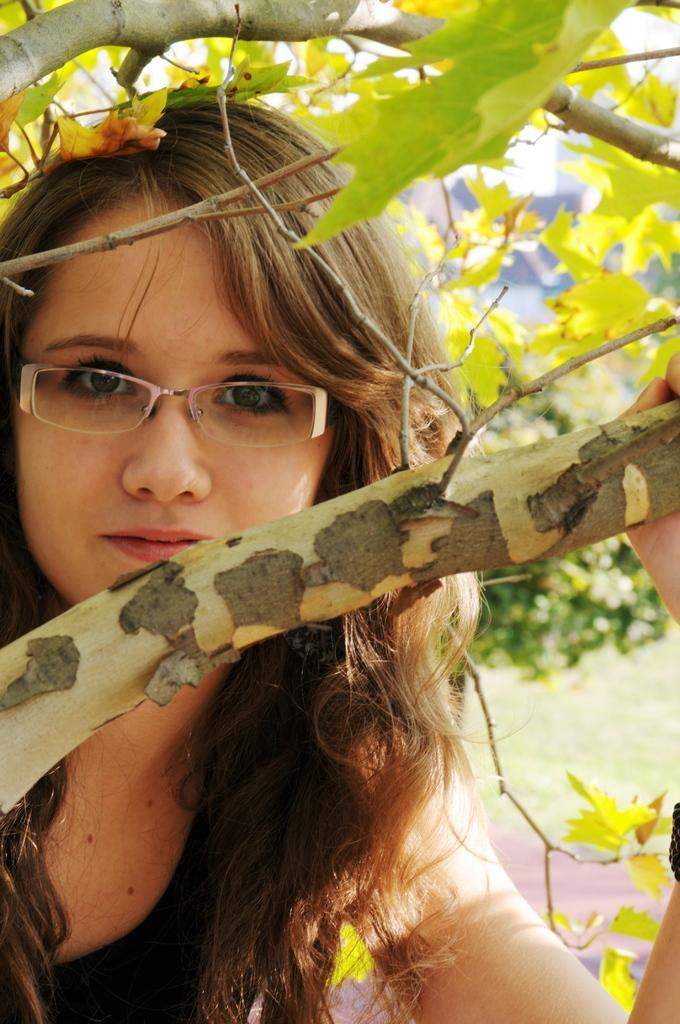What is the main subject of the image? There is a person standing in the image. What is the person wearing? The person is wearing a black dress. What can be seen in the background of the image? There are trees and the sky visible in the background of the image. What is the color of the trees in the image? The trees are green. What is the color of the sky in the image? The sky is white. What type of flag can be seen in the image? There is no flag present in the image. How many roots can be seen growing from the person's feet in the image? There are no roots visible in the image; the person is standing on the ground. 